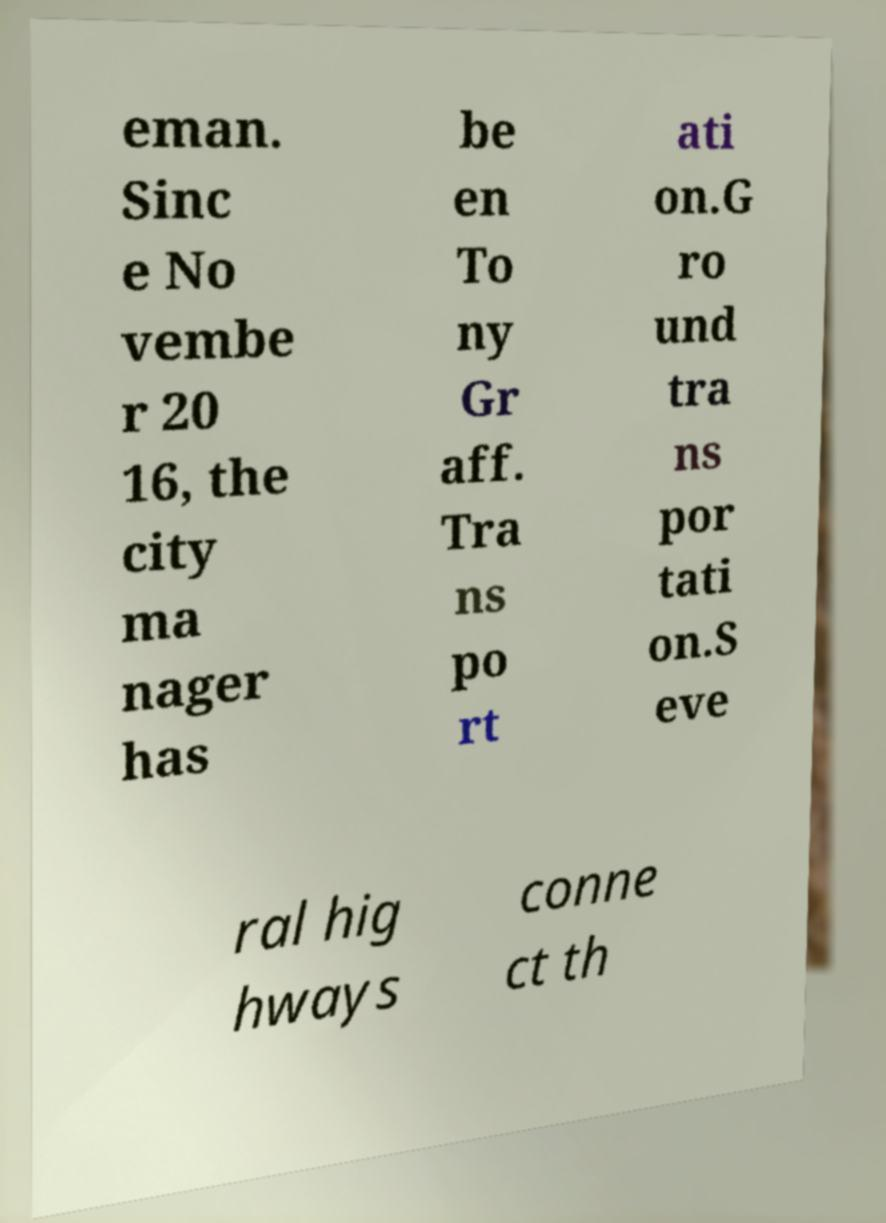Please identify and transcribe the text found in this image. eman. Sinc e No vembe r 20 16, the city ma nager has be en To ny Gr aff. Tra ns po rt ati on.G ro und tra ns por tati on.S eve ral hig hways conne ct th 